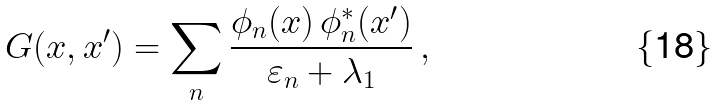Convert formula to latex. <formula><loc_0><loc_0><loc_500><loc_500>G ( x , x ^ { \prime } ) = \sum _ { n } \frac { \phi _ { n } ( x ) \, \phi _ { n } ^ { * } ( x ^ { \prime } ) } { \varepsilon _ { n } + \lambda _ { 1 } } \, ,</formula> 